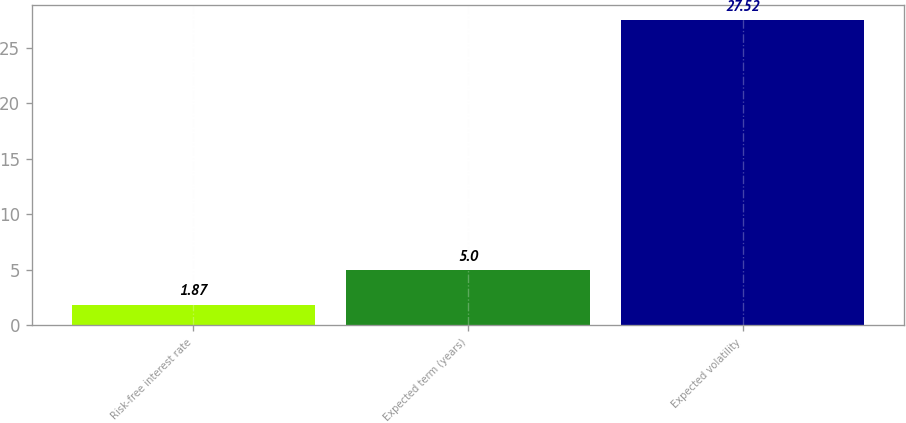<chart> <loc_0><loc_0><loc_500><loc_500><bar_chart><fcel>Risk-free interest rate<fcel>Expected term (years)<fcel>Expected volatility<nl><fcel>1.87<fcel>5<fcel>27.52<nl></chart> 